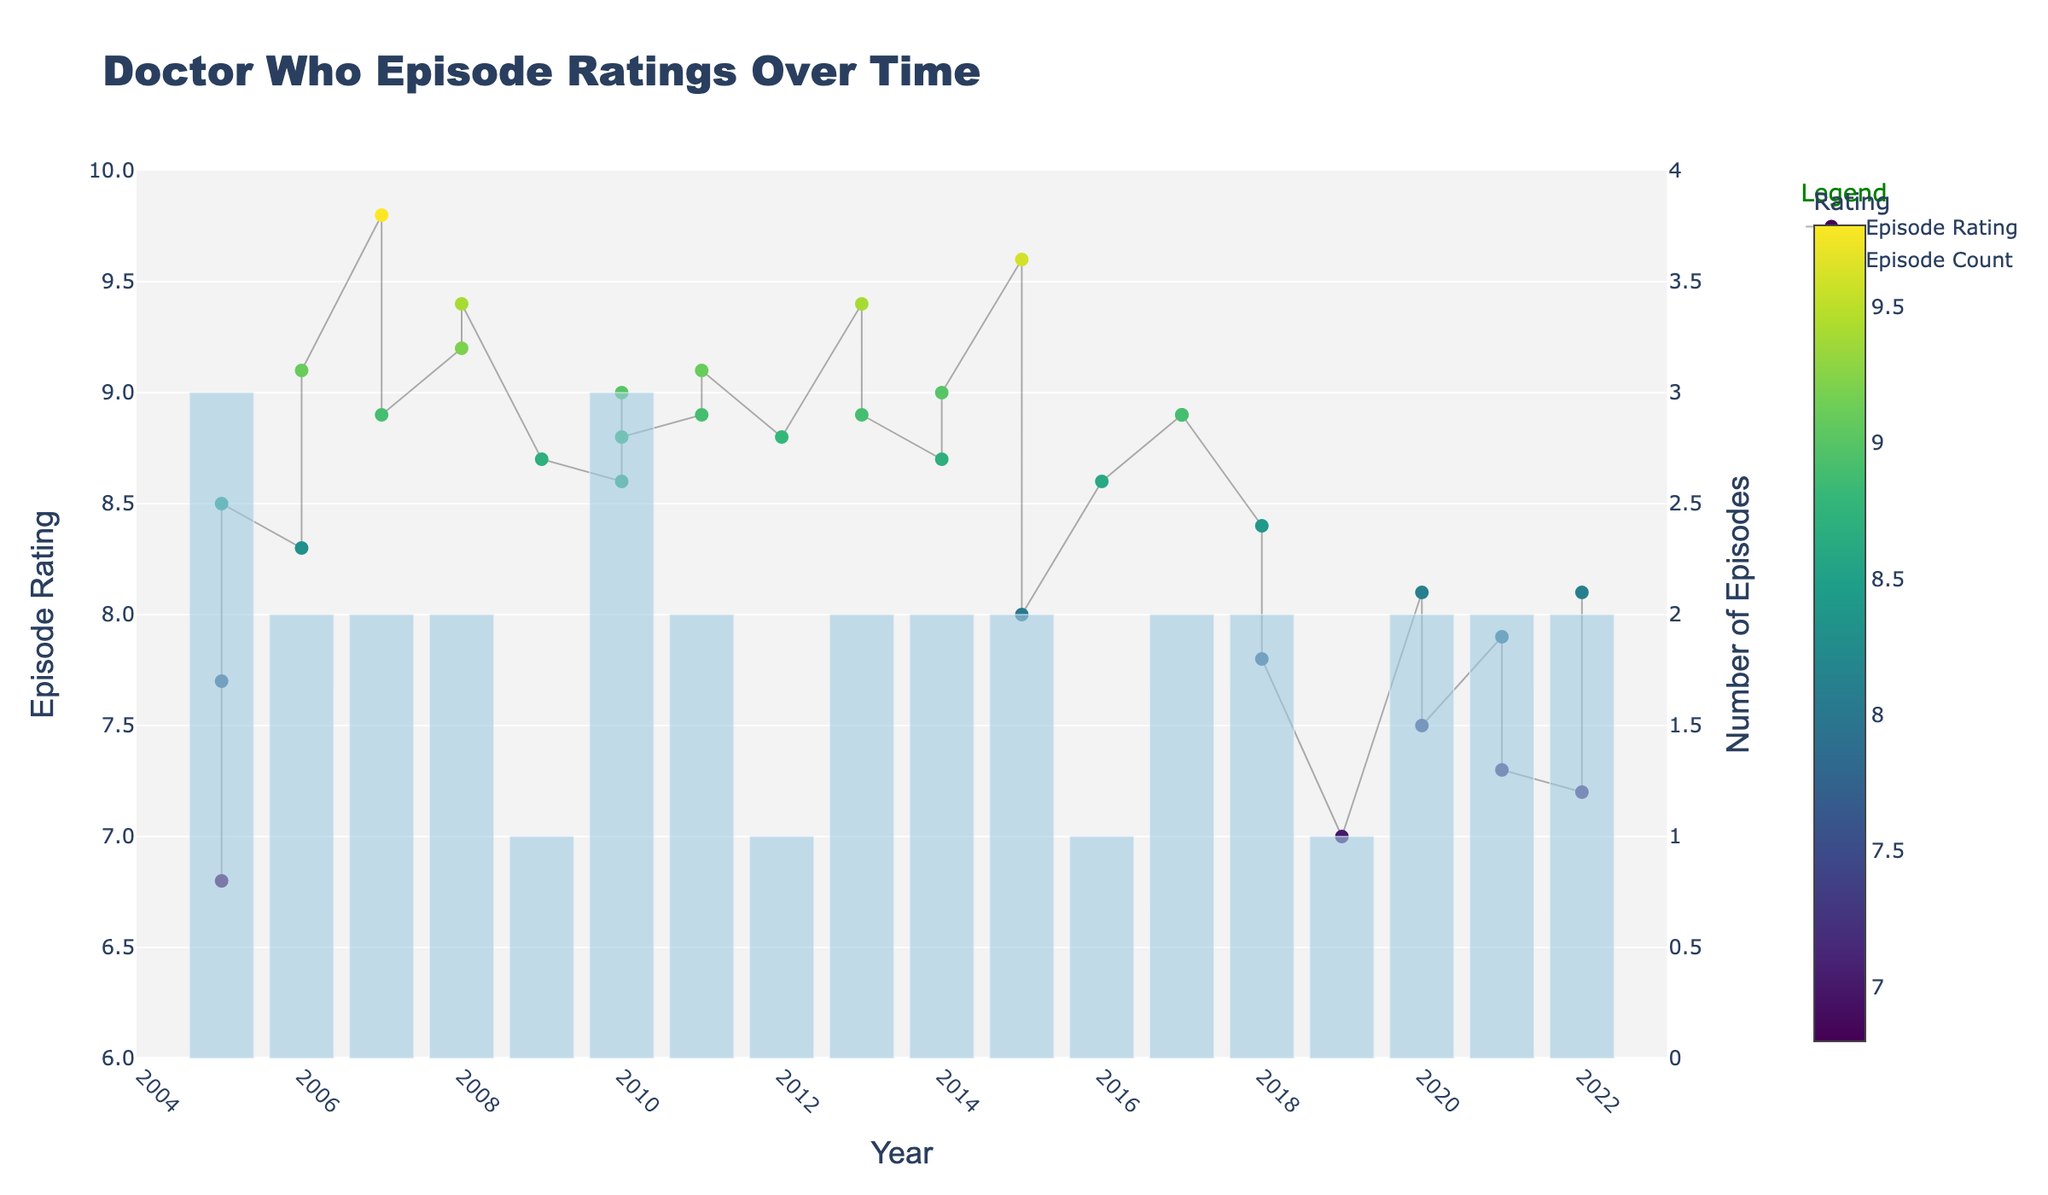What is the title of the figure? The title is at the top of the figure, clearly stating the main topic that the visual represents.
Answer: Doctor Who Episode Ratings Over Time What does the color of the markers represent in the scatter plot? The color of the markers is encoded as a gradient, where different shades represent different values. The color bar next to the plot specifies the relationship between color and rating.
Answer: Episode rating Which year has the highest episode rating, and what is that rating? By locating the highest point on the scatter plot and reading the corresponding year and rating from the axes, we identify the year and rating.
Answer: 2007, 9.8 How many episodes were aired in 2010, and what are their ratings? Look at the bar plot for the number of episodes in 2010 and then refer to the scatter plot markers for their specific ratings.
Answer: 3 episodes, ratings are 8.6, 9.0, 8.8 Compare the episode ratings of 2009 and 2010. Which year had higher ratings on average? Calculate the average rating for each of the years by summing the ratings and dividing by the number of episodes. For 2009, there's only one rating of 8.7. For 2010, the average is (8.6 + 9.0 + 8.8) / 3 = 8.8.
Answer: 2010 had higher ratings on average What is the trend in episode ratings from 2018 to 2022? Identify the series of data points corresponding to each year from 2018 to 2022 in the scatter plot and observe the pattern they form.
Answer: The trend is slightly decreasing overall In which year do you see the maximum number of episodes, and how many episodes were there? Look at the bar plot and identify the tallest bar, then read the year and the height of the bar.
Answer: 2010, 3 episodes Which episode has the lowest rating, and in which year was it aired? Identify the lowest point on the scatter plot and read the corresponding episode name and year.
Answer: "Rose", 2005 How does the episode count per year trend over time? By looking at the bar chart and observing the changes in the bar heights over years, you can determine the trend in the number of episodes aired.
Answer: Varies with no consistent trend Are there any years where the episode ratings are consistently above 8.5? Scan the scatter plot to identify years where all episode ratings are above 8.5. Summarize these years and their episode ratings from the plot.
Answer: 2007, 2008, 2010, 2011, 2013, 2014, 2015, 2017 